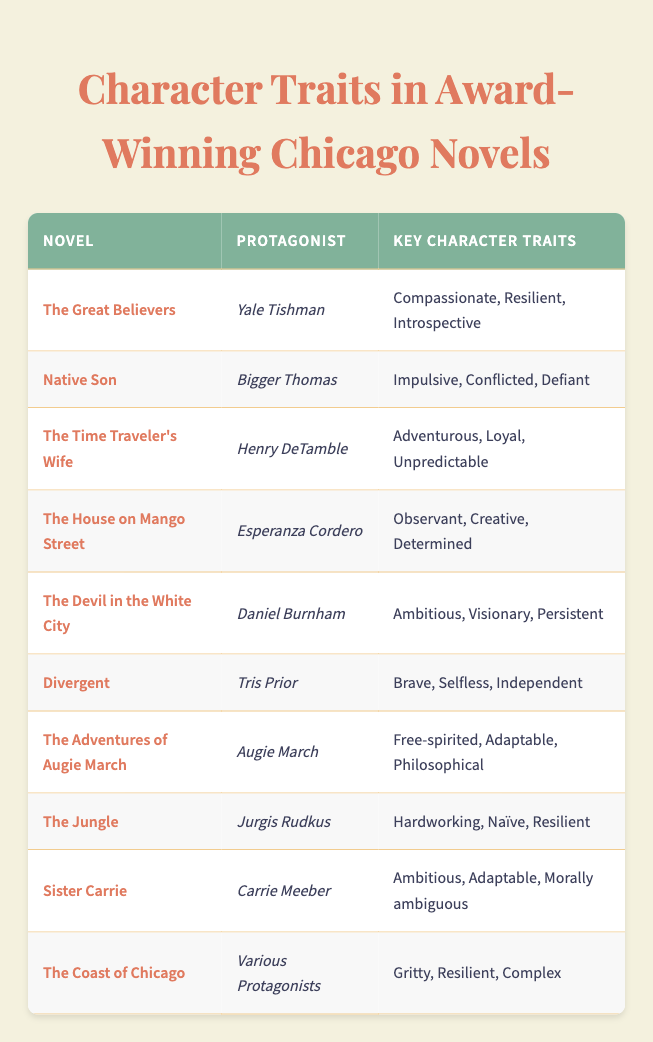What are the key character traits of Yale Tishman? Referring to the table, the entry for "The Great Believers" lists "Yale Tishman" with the key character traits as "Compassionate, Resilient, Introspective."
Answer: Compassionate, Resilient, Introspective Which protagonist is described as "Brave, Selfless, Independent"? The table indicates that "Tris Prior" from "Divergent" is described with these character traits.
Answer: Tris Prior How many protagonists are described as "Resilient"? By reviewing each row in the table, the protagonists with "Resilient" as a key trait are Yale Tishman, Jurgis Rudkus, and the various protagonists from "The Coast of Chicago." This gives us a total of three instances.
Answer: 3 Is Esperanza Cordero from "The House on Mango Street" characterized as "Creative"? The character traits listed for Esperanza Cordero in the table include "Creative." Therefore, the statement is true.
Answer: Yes Which protagonist has the traits "Ambitious, Visionary, Persistent"? The table clearly states that the protagonist from "The Devil in the White City," named Daniel Burnham, has these specific traits listed.
Answer: Daniel Burnham What is the common character trait shared by Jurgis Rudkus and Tris Prior? Looking at the traits for Jurgis Rudkus (Hardworking, Naïve, Resilient) and Tris Prior (Brave, Selfless, Independent), the common trait between them is "Resilient."
Answer: Resilient How would you categorize the character traits of the protagonist from "The Coast of Chicago"? The table describes various protagonists from "The Coast of Chicago" as having "Gritty, Resilient, Complex" traits. This suggests that the character traits are nuanced and depict a deeper narrative complexity.
Answer: Gritty, Resilient, Complex Which novel features a protagonist that is "Impulsive, Conflicted, Defiant"? Referring to the table, the protagonist with those traits is Bigger Thomas from "Native Son." The novel and character align correctly as stated.
Answer: Native Son Count the total number of different novels represented in the table. There are a total of ten entries in the table, each representing a different novel. Therefore, the total count of different novels is ten.
Answer: 10 